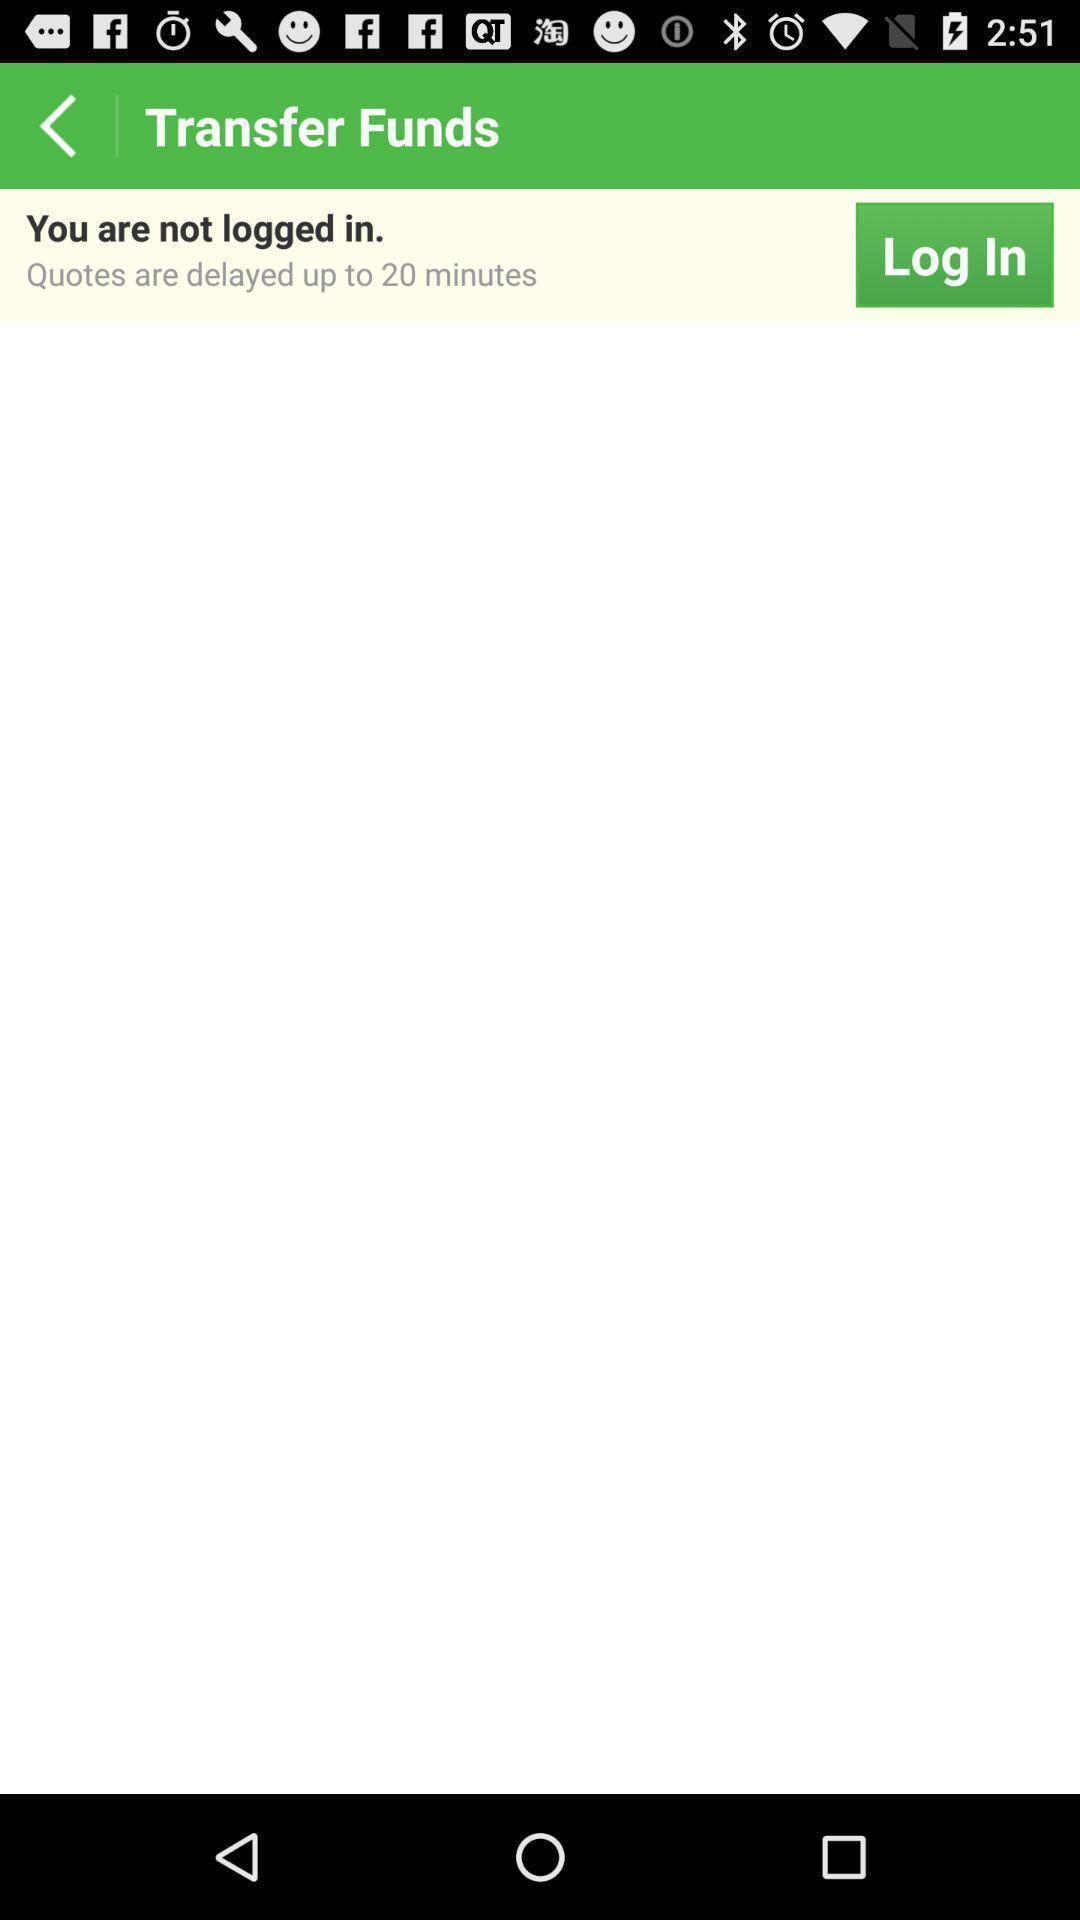Describe the visual elements of this screenshot. Screen shows about transfer funds. 